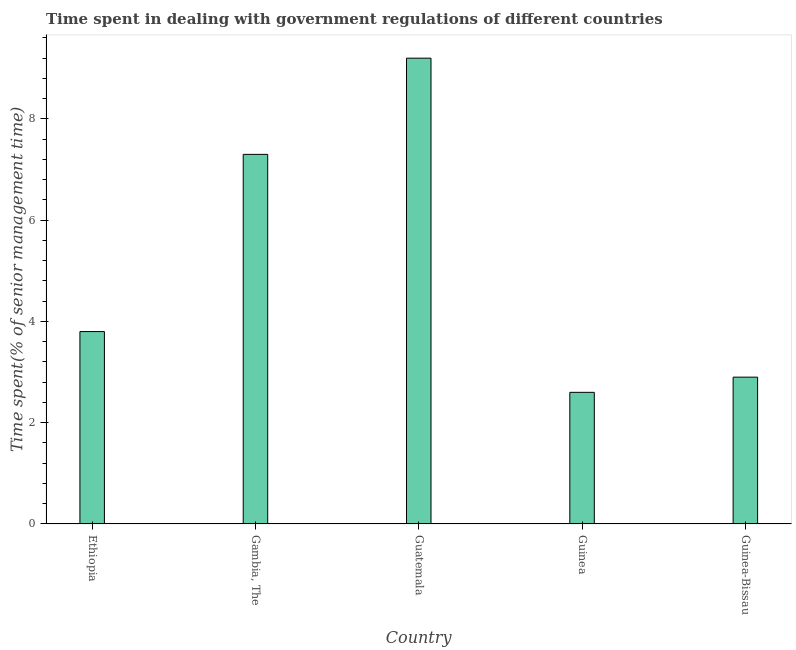Does the graph contain any zero values?
Your response must be concise. No. What is the title of the graph?
Make the answer very short. Time spent in dealing with government regulations of different countries. What is the label or title of the Y-axis?
Give a very brief answer. Time spent(% of senior management time). Across all countries, what is the maximum time spent in dealing with government regulations?
Offer a terse response. 9.2. Across all countries, what is the minimum time spent in dealing with government regulations?
Offer a terse response. 2.6. In which country was the time spent in dealing with government regulations maximum?
Make the answer very short. Guatemala. In which country was the time spent in dealing with government regulations minimum?
Offer a very short reply. Guinea. What is the sum of the time spent in dealing with government regulations?
Provide a short and direct response. 25.8. What is the average time spent in dealing with government regulations per country?
Provide a short and direct response. 5.16. What is the median time spent in dealing with government regulations?
Give a very brief answer. 3.8. What is the ratio of the time spent in dealing with government regulations in Gambia, The to that in Guinea?
Make the answer very short. 2.81. Is the difference between the time spent in dealing with government regulations in Ethiopia and Guinea-Bissau greater than the difference between any two countries?
Provide a short and direct response. No. What is the difference between the highest and the lowest time spent in dealing with government regulations?
Ensure brevity in your answer.  6.6. In how many countries, is the time spent in dealing with government regulations greater than the average time spent in dealing with government regulations taken over all countries?
Your answer should be compact. 2. How many bars are there?
Your answer should be very brief. 5. Are all the bars in the graph horizontal?
Offer a very short reply. No. How many countries are there in the graph?
Ensure brevity in your answer.  5. What is the Time spent(% of senior management time) of Ethiopia?
Make the answer very short. 3.8. What is the Time spent(% of senior management time) in Guatemala?
Your answer should be compact. 9.2. What is the Time spent(% of senior management time) of Guinea-Bissau?
Give a very brief answer. 2.9. What is the difference between the Time spent(% of senior management time) in Ethiopia and Gambia, The?
Ensure brevity in your answer.  -3.5. What is the difference between the Time spent(% of senior management time) in Ethiopia and Guinea?
Offer a very short reply. 1.2. What is the difference between the Time spent(% of senior management time) in Gambia, The and Guinea?
Offer a terse response. 4.7. What is the difference between the Time spent(% of senior management time) in Gambia, The and Guinea-Bissau?
Give a very brief answer. 4.4. What is the difference between the Time spent(% of senior management time) in Guatemala and Guinea-Bissau?
Offer a very short reply. 6.3. What is the difference between the Time spent(% of senior management time) in Guinea and Guinea-Bissau?
Keep it short and to the point. -0.3. What is the ratio of the Time spent(% of senior management time) in Ethiopia to that in Gambia, The?
Provide a short and direct response. 0.52. What is the ratio of the Time spent(% of senior management time) in Ethiopia to that in Guatemala?
Give a very brief answer. 0.41. What is the ratio of the Time spent(% of senior management time) in Ethiopia to that in Guinea?
Offer a very short reply. 1.46. What is the ratio of the Time spent(% of senior management time) in Ethiopia to that in Guinea-Bissau?
Your answer should be compact. 1.31. What is the ratio of the Time spent(% of senior management time) in Gambia, The to that in Guatemala?
Offer a very short reply. 0.79. What is the ratio of the Time spent(% of senior management time) in Gambia, The to that in Guinea?
Provide a short and direct response. 2.81. What is the ratio of the Time spent(% of senior management time) in Gambia, The to that in Guinea-Bissau?
Make the answer very short. 2.52. What is the ratio of the Time spent(% of senior management time) in Guatemala to that in Guinea?
Your answer should be compact. 3.54. What is the ratio of the Time spent(% of senior management time) in Guatemala to that in Guinea-Bissau?
Offer a terse response. 3.17. What is the ratio of the Time spent(% of senior management time) in Guinea to that in Guinea-Bissau?
Offer a terse response. 0.9. 